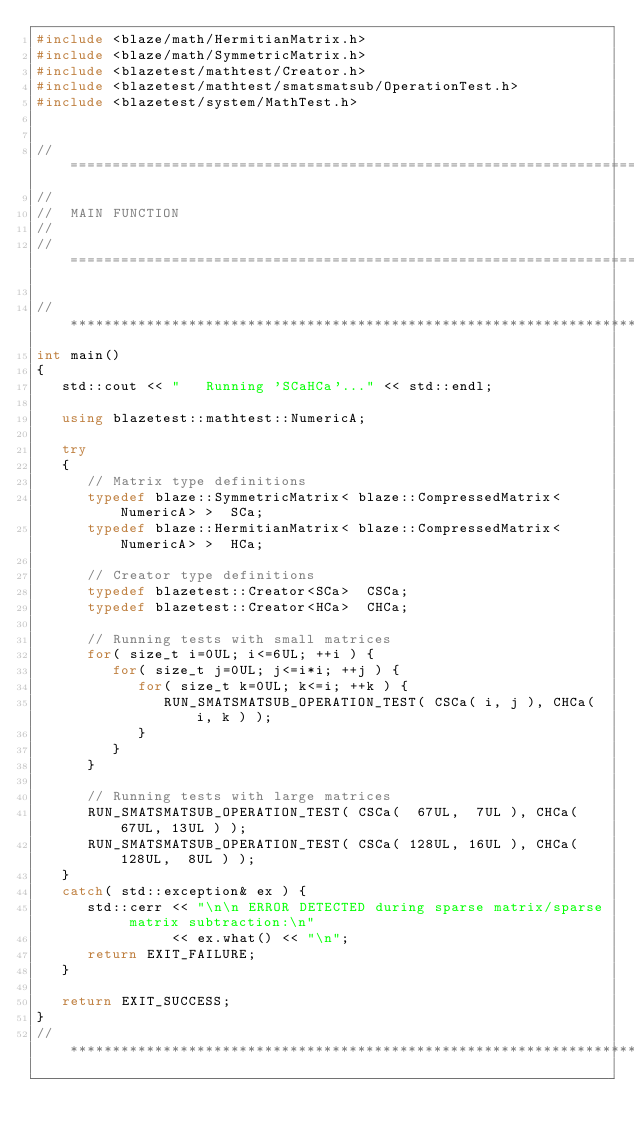Convert code to text. <code><loc_0><loc_0><loc_500><loc_500><_C++_>#include <blaze/math/HermitianMatrix.h>
#include <blaze/math/SymmetricMatrix.h>
#include <blazetest/mathtest/Creator.h>
#include <blazetest/mathtest/smatsmatsub/OperationTest.h>
#include <blazetest/system/MathTest.h>


//=================================================================================================
//
//  MAIN FUNCTION
//
//=================================================================================================

//*************************************************************************************************
int main()
{
   std::cout << "   Running 'SCaHCa'..." << std::endl;

   using blazetest::mathtest::NumericA;

   try
   {
      // Matrix type definitions
      typedef blaze::SymmetricMatrix< blaze::CompressedMatrix<NumericA> >  SCa;
      typedef blaze::HermitianMatrix< blaze::CompressedMatrix<NumericA> >  HCa;

      // Creator type definitions
      typedef blazetest::Creator<SCa>  CSCa;
      typedef blazetest::Creator<HCa>  CHCa;

      // Running tests with small matrices
      for( size_t i=0UL; i<=6UL; ++i ) {
         for( size_t j=0UL; j<=i*i; ++j ) {
            for( size_t k=0UL; k<=i; ++k ) {
               RUN_SMATSMATSUB_OPERATION_TEST( CSCa( i, j ), CHCa( i, k ) );
            }
         }
      }

      // Running tests with large matrices
      RUN_SMATSMATSUB_OPERATION_TEST( CSCa(  67UL,  7UL ), CHCa(  67UL, 13UL ) );
      RUN_SMATSMATSUB_OPERATION_TEST( CSCa( 128UL, 16UL ), CHCa( 128UL,  8UL ) );
   }
   catch( std::exception& ex ) {
      std::cerr << "\n\n ERROR DETECTED during sparse matrix/sparse matrix subtraction:\n"
                << ex.what() << "\n";
      return EXIT_FAILURE;
   }

   return EXIT_SUCCESS;
}
//*************************************************************************************************
</code> 